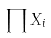<formula> <loc_0><loc_0><loc_500><loc_500>\prod X _ { i }</formula> 